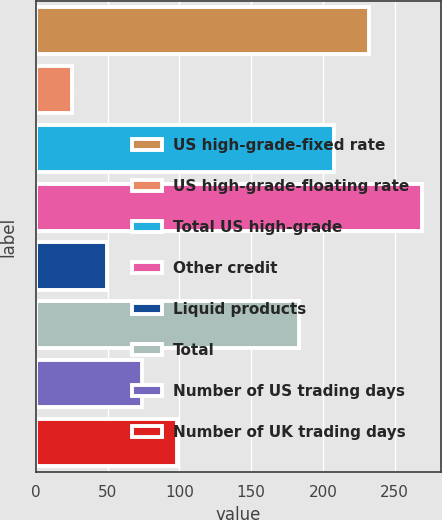Convert chart to OTSL. <chart><loc_0><loc_0><loc_500><loc_500><bar_chart><fcel>US high-grade-fixed rate<fcel>US high-grade-floating rate<fcel>Total US high-grade<fcel>Other credit<fcel>Liquid products<fcel>Total<fcel>Number of US trading days<fcel>Number of UK trading days<nl><fcel>231.8<fcel>25<fcel>207.4<fcel>269<fcel>49.4<fcel>183<fcel>73.8<fcel>98.2<nl></chart> 